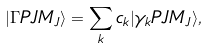Convert formula to latex. <formula><loc_0><loc_0><loc_500><loc_500>| \Gamma P J M _ { J } \rangle = \sum _ { k } c _ { k } | \gamma _ { k } P J M _ { J } \rangle ,</formula> 